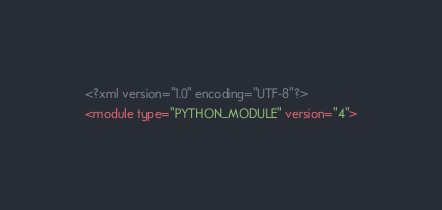<code> <loc_0><loc_0><loc_500><loc_500><_XML_><?xml version="1.0" encoding="UTF-8"?>
<module type="PYTHON_MODULE" version="4"></code> 